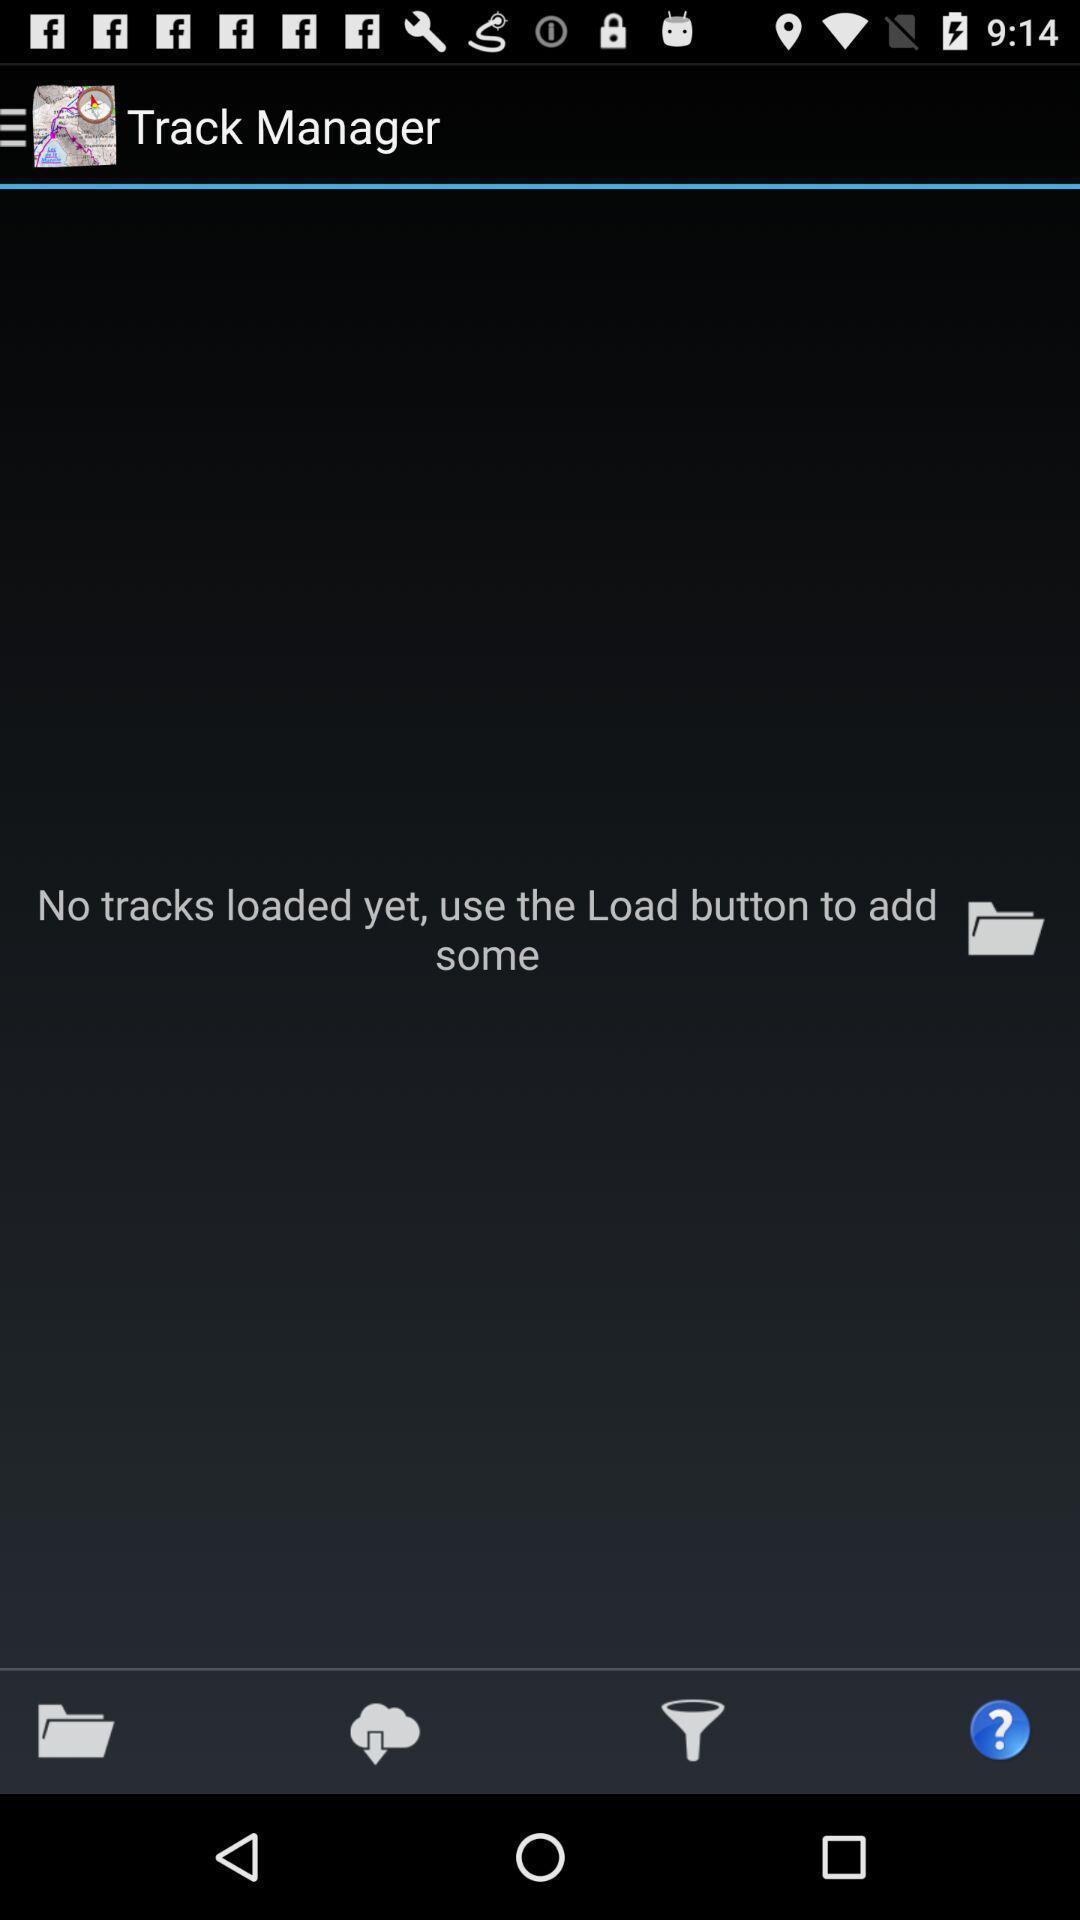Provide a description of this screenshot. Screen page displaying the status of track records in application. 